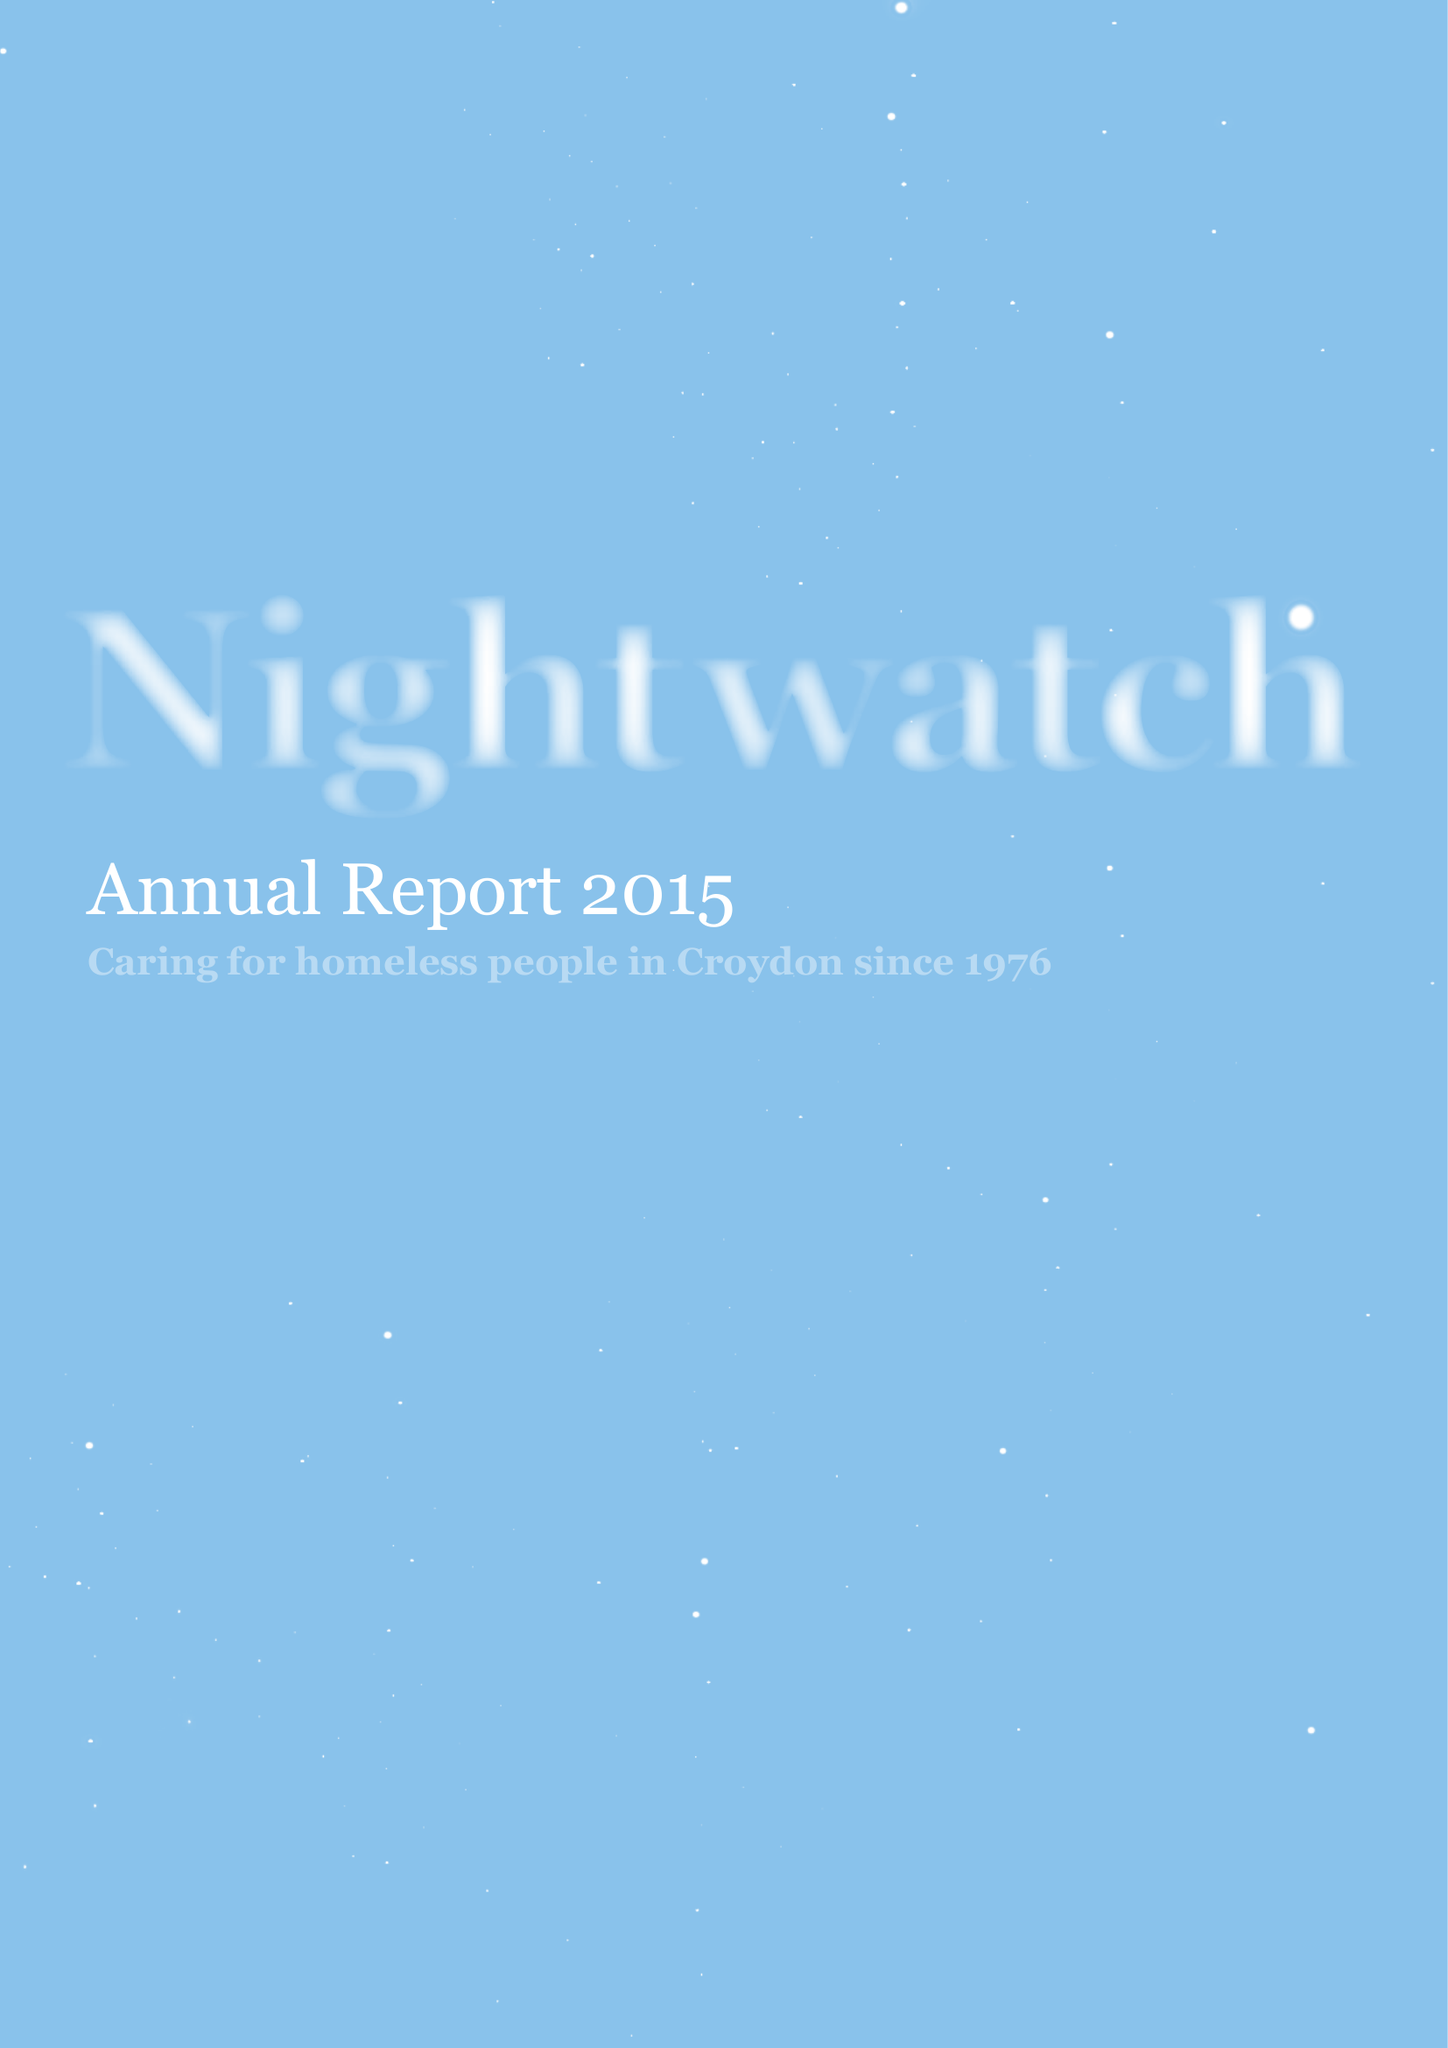What is the value for the spending_annually_in_british_pounds?
Answer the question using a single word or phrase. 39501.00 